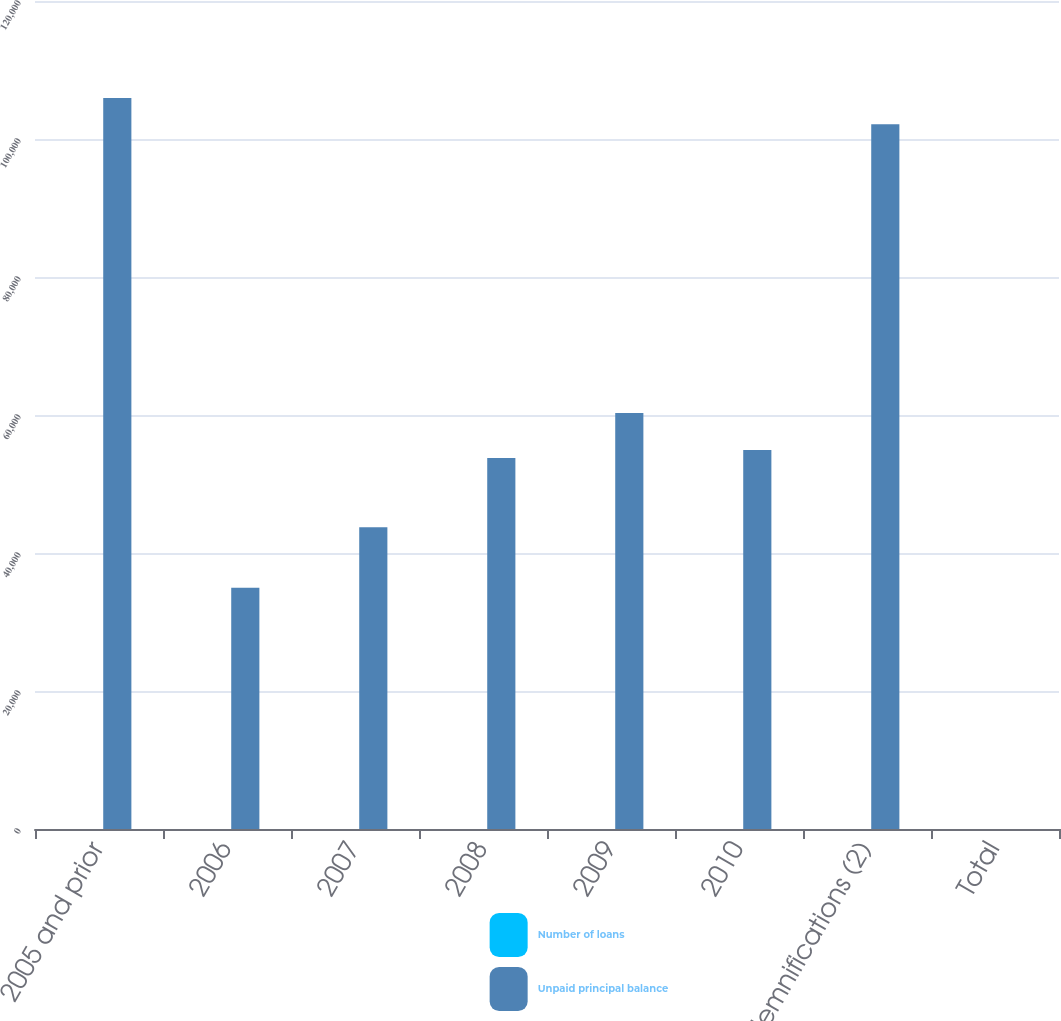Convert chart. <chart><loc_0><loc_0><loc_500><loc_500><stacked_bar_chart><ecel><fcel>2005 and prior<fcel>2006<fcel>2007<fcel>2008<fcel>2009<fcel>2010<fcel>Indemnifications (2)<fcel>Total<nl><fcel>Number of loans<fcel>1<fcel>0.2<fcel>0.2<fcel>0.3<fcel>0.3<fcel>0.3<fcel>0.9<fcel>3.2<nl><fcel>Unpaid principal balance<fcel>105931<fcel>34969<fcel>43744<fcel>53759<fcel>60293<fcel>54936<fcel>102142<fcel>3.2<nl></chart> 